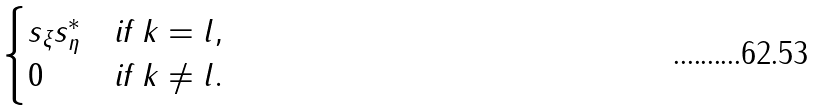Convert formula to latex. <formula><loc_0><loc_0><loc_500><loc_500>\begin{cases} s _ { \xi } s _ { \eta } ^ { * } & \text {if $k=l$} , \\ 0 & \text {if $k\neq l$} . \end{cases}</formula> 